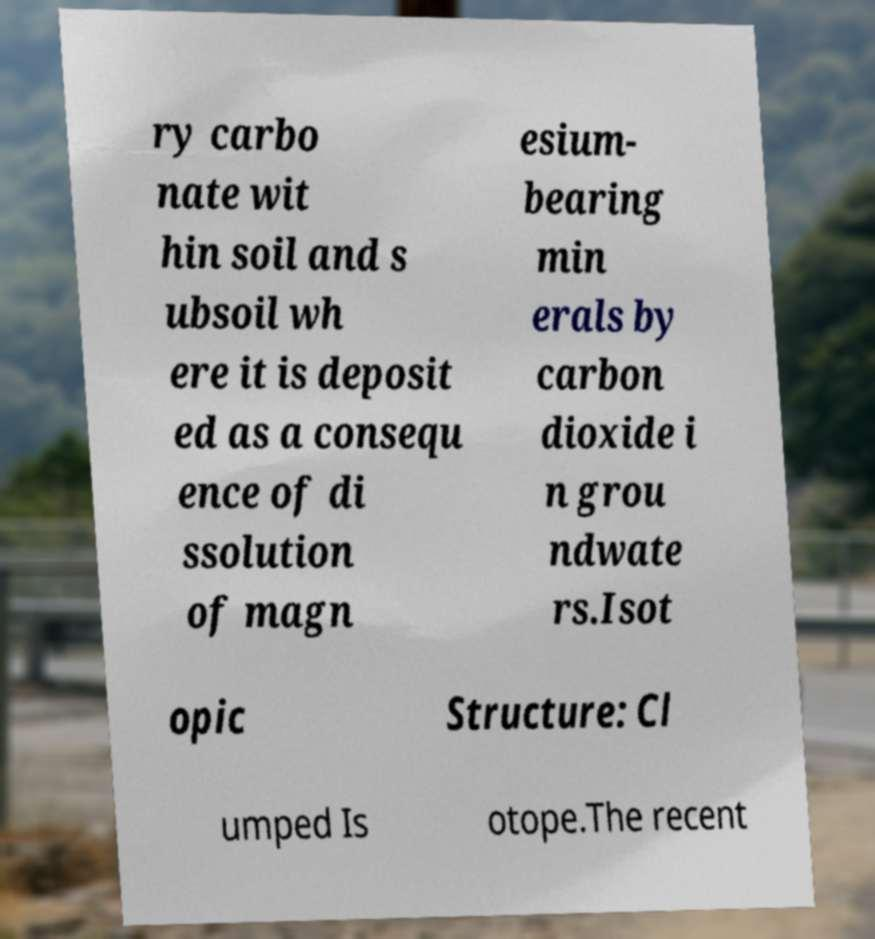Could you assist in decoding the text presented in this image and type it out clearly? ry carbo nate wit hin soil and s ubsoil wh ere it is deposit ed as a consequ ence of di ssolution of magn esium- bearing min erals by carbon dioxide i n grou ndwate rs.Isot opic Structure: Cl umped Is otope.The recent 